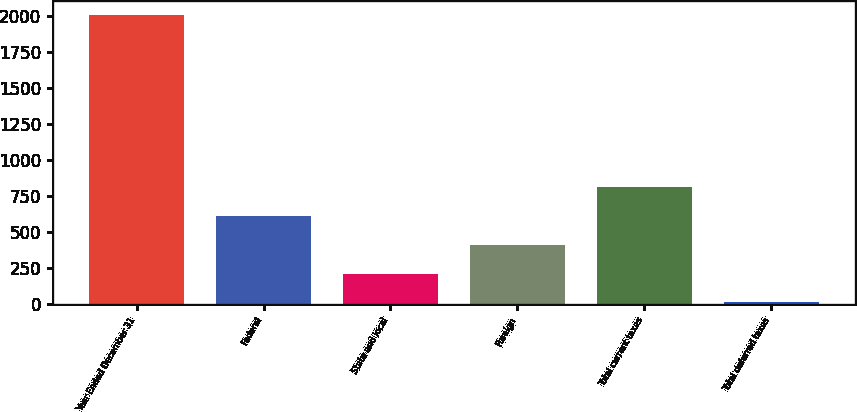Convert chart. <chart><loc_0><loc_0><loc_500><loc_500><bar_chart><fcel>Year Ended December 31<fcel>Federal<fcel>State and local<fcel>Foreign<fcel>Total current taxes<fcel>Total deferred taxes<nl><fcel>2006<fcel>610.83<fcel>212.21<fcel>411.52<fcel>810.14<fcel>12.9<nl></chart> 